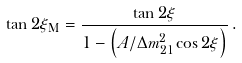<formula> <loc_0><loc_0><loc_500><loc_500>\tan 2 \xi _ { \text {M} } = \frac { \tan 2 \xi } { 1 - \left ( A / \Delta { m } ^ { 2 } _ { 2 1 } \cos 2 \xi \right ) } \, .</formula> 